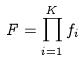Convert formula to latex. <formula><loc_0><loc_0><loc_500><loc_500>F = \prod _ { i = 1 } ^ { K } f _ { i }</formula> 